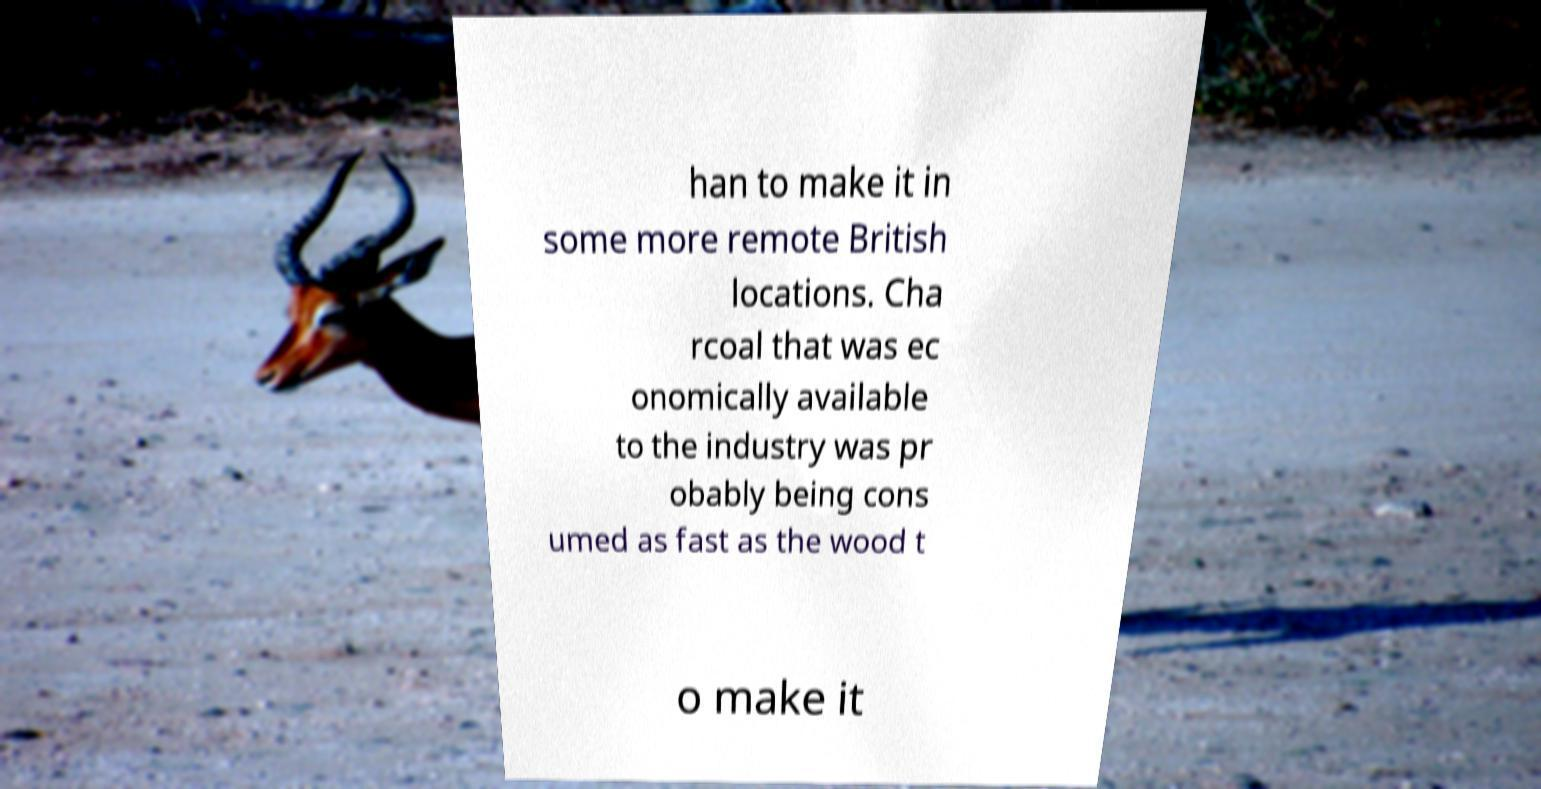Can you accurately transcribe the text from the provided image for me? han to make it in some more remote British locations. Cha rcoal that was ec onomically available to the industry was pr obably being cons umed as fast as the wood t o make it 